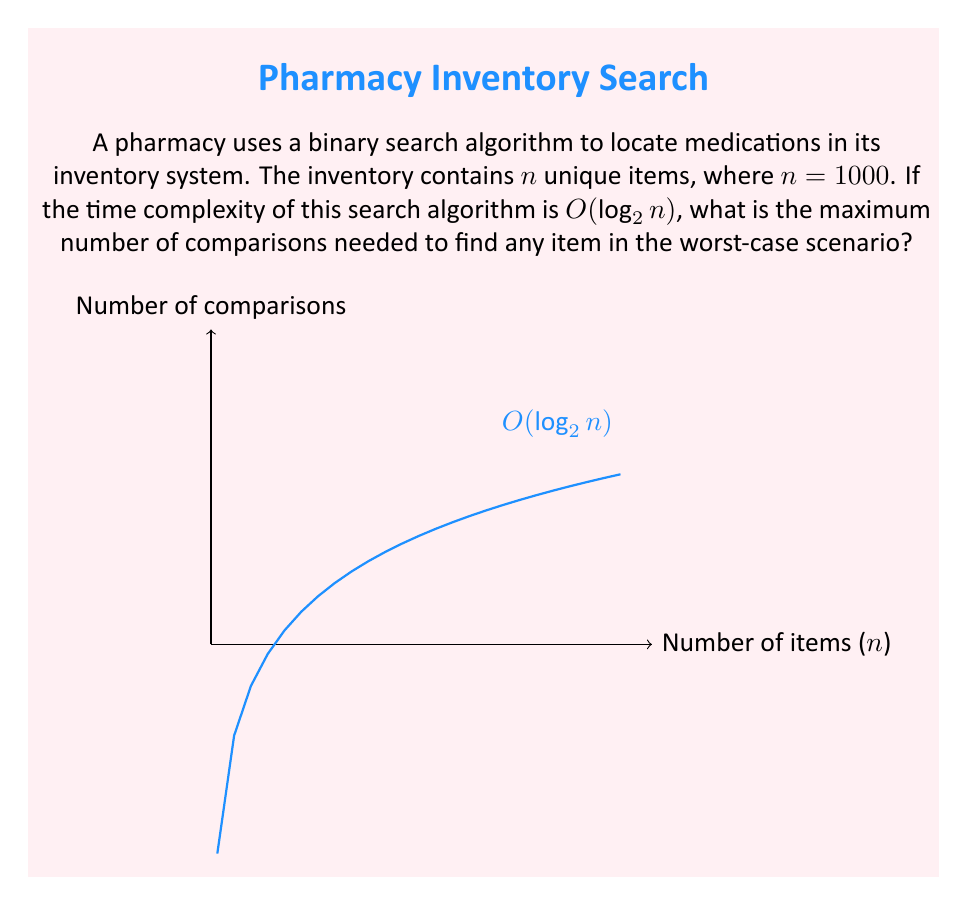Can you answer this question? To solve this problem, we need to follow these steps:

1) The time complexity of binary search is $O(\log_2 n)$, where $n$ is the number of items.

2) In the worst-case scenario, the maximum number of comparisons is equal to $\lfloor \log_2 n \rfloor + 1$, where $\lfloor \cdot \rfloor$ denotes the floor function.

3) We are given that $n = 1000$.

4) Let's calculate $\log_2 1000$:

   $\log_2 1000 \approx 9.9658$

5) Taking the floor of this value:

   $\lfloor \log_2 1000 \rfloor = 9$

6) Adding 1 to this value:

   $\lfloor \log_2 1000 \rfloor + 1 = 9 + 1 = 10$

Therefore, the maximum number of comparisons needed in the worst-case scenario is 10.

This result means that for an inventory of 1000 items, the pharmacy technician would need to perform at most 10 comparisons to find any item, ensuring efficient stock management.
Answer: 10 comparisons 